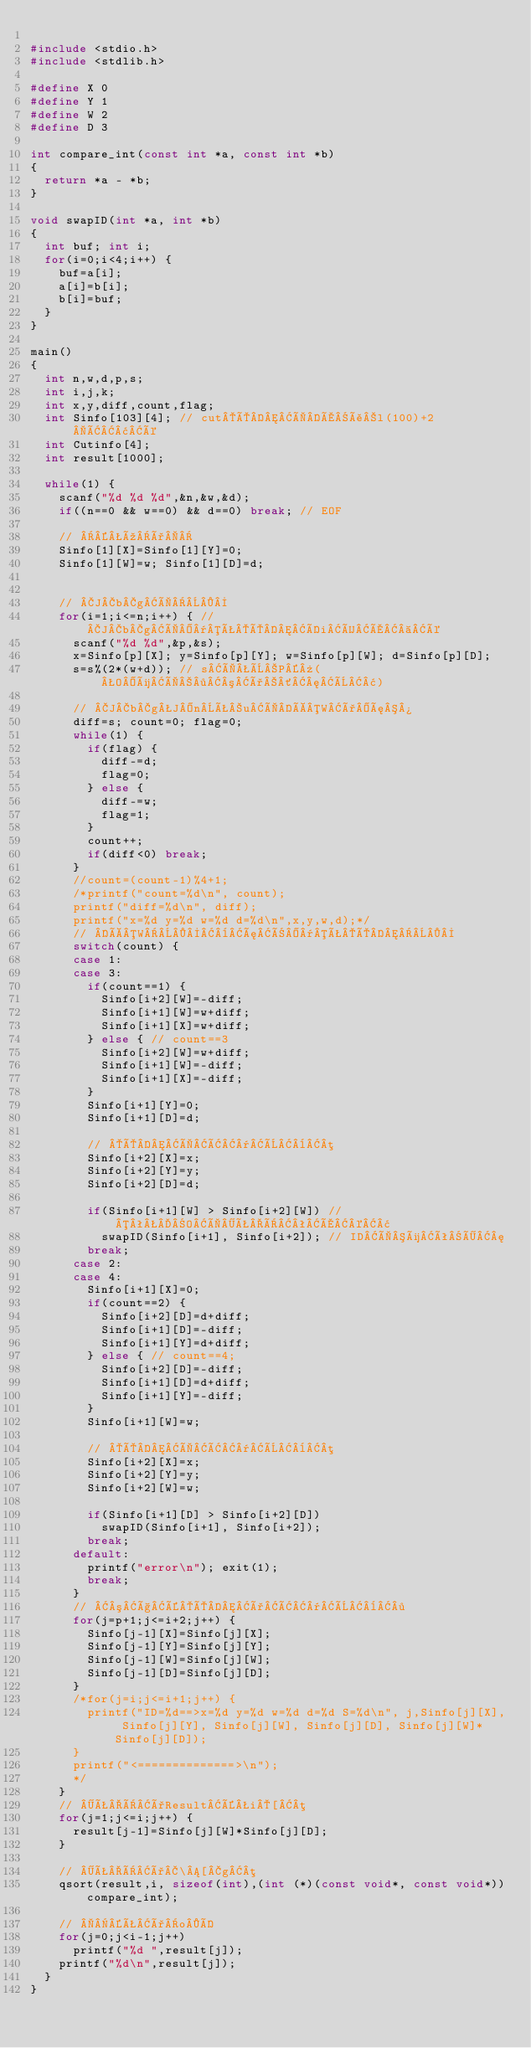<code> <loc_0><loc_0><loc_500><loc_500><_C_>
#include <stdio.h>
#include <stdlib.h>

#define X 0
#define Y 1
#define W 2
#define D 3

int compare_int(const int *a, const int *b)
{
  return *a - *b;
}

void swapID(int *a, int *b)
{
  int buf; int i;
  for(i=0;i<4;i++) {
    buf=a[i];
    a[i]=b[i];
    b[i]=buf;
  }
}

main()
{
  int n,w,d,p,s;
  int i,j,k;
  int x,y,diff,count,flag;
  int Sinfo[103][4]; // cutÔÌÅål(100)+2Â¢é
  int Cutinfo[4];
  int result[1000];

  while(1) {
    scanf("%d %d %d",&n,&w,&d);
    if((n==0 && w==0) && d==0) break; // EOF

    // úð
    Sinfo[1][X]=Sinfo[1][Y]=0;
    Sinfo[1][W]=w; Sinfo[1][D]=d;


    // JbgÌ
    for(i=1;i<=n;i++) { // JbgÌ¯ÊÔÍiÜÅ é
      scanf("%d %d",&p,&s);
      x=Sinfo[p][X]; y=Sinfo[p][Y]; w=Sinfo[p][W]; d=Sinfo[p][D];
      s=s%(2*(w+d)); // sÌÈP»(OüÌ·³ð´¦È¢)

      // JbgJnÊuÌÀWðæ¾
      diff=s; count=0; flag=0;
      while(1) {
        if(flag) {
          diff-=d;
          flag=0;
        } else {
          diff-=w;
          flag=1;
        }
        count++;
        if(diff<0) break;
      }
      //count=(count-1)%4+1;
      /*printf("count=%d\n", count);
      printf("diff=%d\n", diff);
      printf("x=%d y=%d w=%d d=%d\n",x,y,w,d);*/
      // ÀW¨æÑ¯ÊÔ
      switch(count) {
      case 1:
      case 3:
        if(count==1) {
          Sinfo[i+2][W]=-diff;
          Sinfo[i+1][W]=w+diff;
          Sinfo[i+1][X]=w+diff;
        } else { // count==3
          Sinfo[i+2][W]=w+diff;
          Sinfo[i+1][W]=-diff;
          Sinfo[i+1][X]=-diff;
        }
        Sinfo[i+1][Y]=0;
        Sinfo[i+1][D]=d;

        // ÔÌÂ¯È¨µ
        Sinfo[i+2][X]=x;
        Sinfo[i+2][Y]=y;
        Sinfo[i+2][D]=d;

        if(Sinfo[i+1][W] > Sinfo[i+2][W]) // ªOÌÊÏªÅ©¢
          swapID(Sinfo[i+1], Sinfo[i+2]); // IDÌüêÖ¦
        break;
      case 2:
      case 4:
        Sinfo[i+1][X]=0;
        if(count==2) {
          Sinfo[i+2][D]=d+diff;
          Sinfo[i+1][D]=-diff;
          Sinfo[i+1][Y]=d+diff;
        } else { // count==4;
          Sinfo[i+2][D]=-diff;
          Sinfo[i+1][D]=d+diff;
          Sinfo[i+1][Y]=-diff;
        }
        Sinfo[i+1][W]=w;

        // ÔÌÂ¯È¨µ
        Sinfo[i+2][X]=x;
        Sinfo[i+2][Y]=y;
        Sinfo[i+2][W]=w;

        if(Sinfo[i+1][D] > Sinfo[i+2][D])
          swapID(Sinfo[i+1], Sinfo[i+2]);
        break;
      default:
        printf("error\n"); exit(1);
        break;
      }
      // ³çÉÔðÂ¯È¨·
      for(j=p+1;j<=i+2;j++) {
        Sinfo[j-1][X]=Sinfo[j][X];
        Sinfo[j-1][Y]=Sinfo[j][Y];
        Sinfo[j-1][W]=Sinfo[j][W];
        Sinfo[j-1][D]=Sinfo[j][D];
      }
      /*for(j=i;j<=i+1;j++) {
        printf("ID=%d==>x=%d y=%d w=%d d=%d S=%d\n", j,Sinfo[j][X], Sinfo[j][Y], Sinfo[j][W], Sinfo[j][D], Sinfo[j][W]*Sinfo[j][D]);
      }
      printf("<==============>\n");
      */
    }
    // ÊÏðResultÉi[µ
    for(j=1;j<=i;j++) {
      result[j-1]=Sinfo[j][W]*Sinfo[j][D];
    }

    // ÊÏð\[gµ
    qsort(result,i, sizeof(int),(int (*)(const void*, const void*))compare_int);

    // ÊðoÍ
    for(j=0;j<i-1;j++)
      printf("%d ",result[j]);
    printf("%d\n",result[j]);
  }
}</code> 